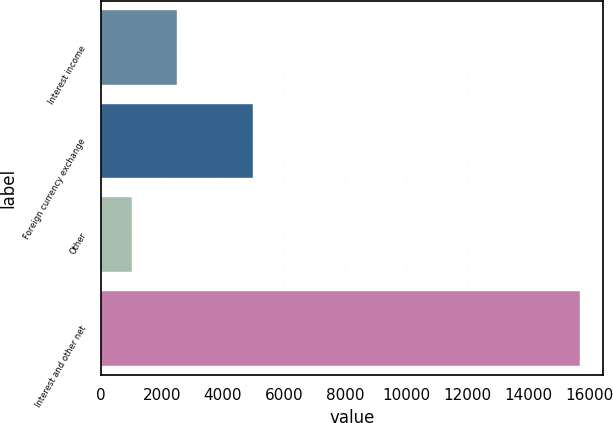<chart> <loc_0><loc_0><loc_500><loc_500><bar_chart><fcel>Interest income<fcel>Foreign currency exchange<fcel>Other<fcel>Interest and other net<nl><fcel>2487<fcel>4990<fcel>1020<fcel>15690<nl></chart> 